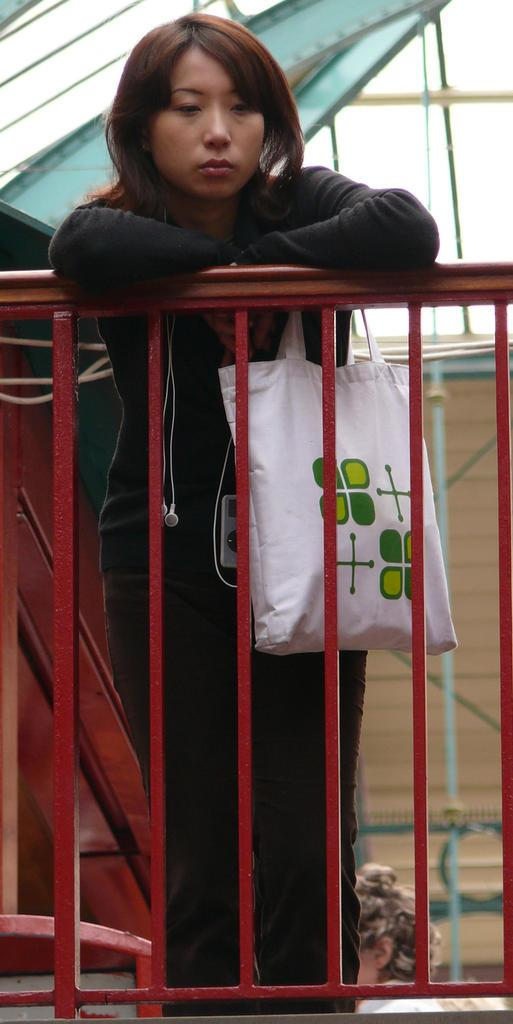What is the woman in the image holding? The woman is holding a white-colored bag. What can be seen in the image besides the woman and the bag? There is a red grill in the image. Can you describe the color of the grill? The grill is red in color. What type of nut is being cracked on the woman's birthday in the image? There is no mention of a nut or a birthday in the image, so we cannot determine if any nut is being cracked. 